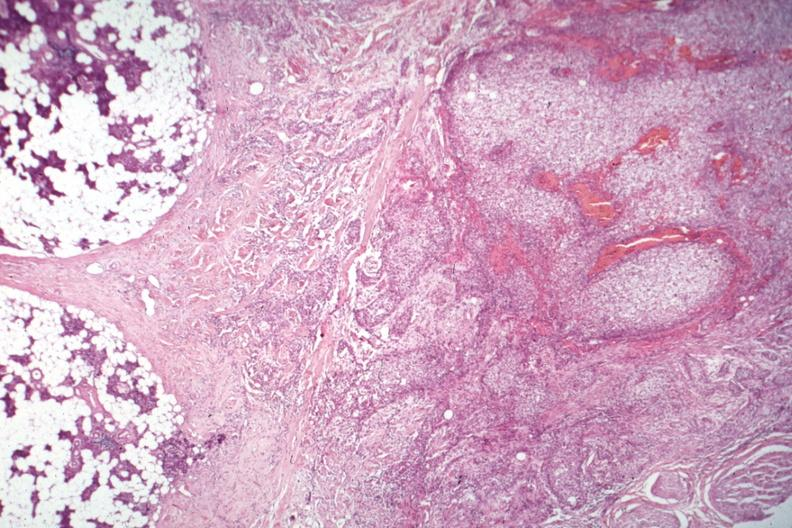s peritoneal fluid present?
Answer the question using a single word or phrase. No 